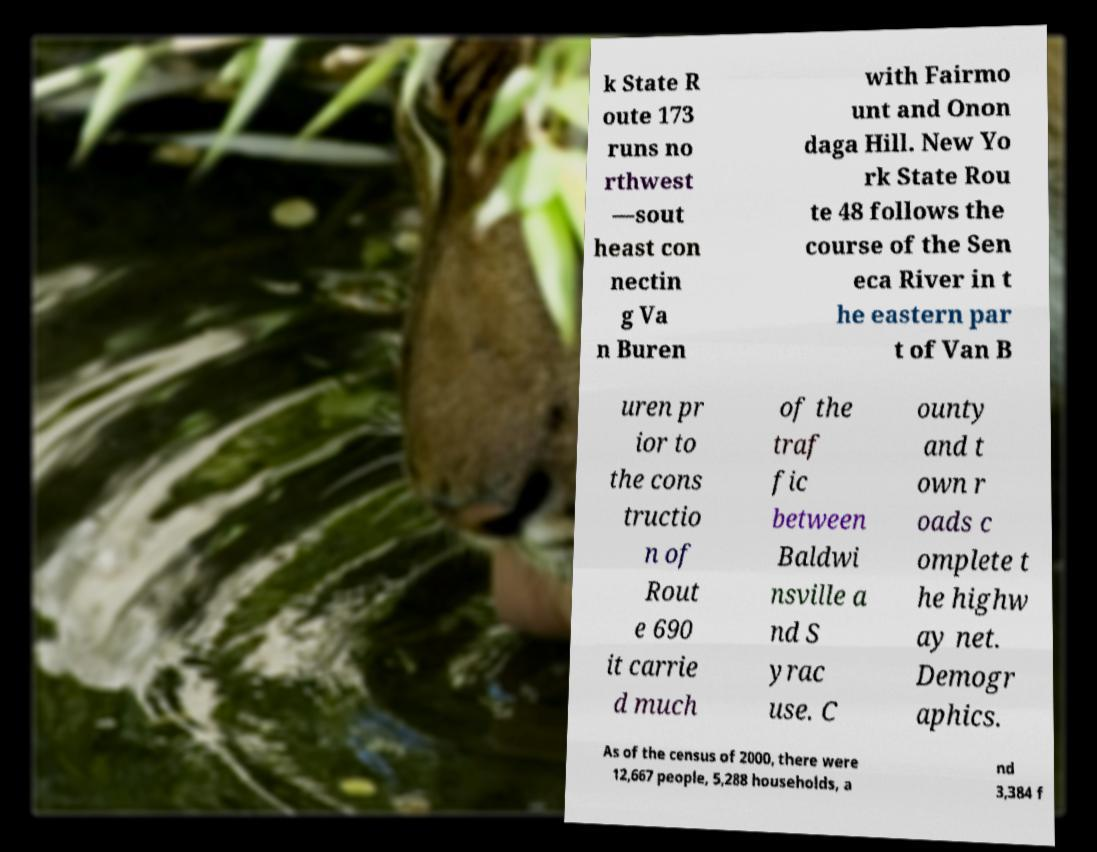Can you read and provide the text displayed in the image?This photo seems to have some interesting text. Can you extract and type it out for me? k State R oute 173 runs no rthwest —sout heast con nectin g Va n Buren with Fairmo unt and Onon daga Hill. New Yo rk State Rou te 48 follows the course of the Sen eca River in t he eastern par t of Van B uren pr ior to the cons tructio n of Rout e 690 it carrie d much of the traf fic between Baldwi nsville a nd S yrac use. C ounty and t own r oads c omplete t he highw ay net. Demogr aphics. As of the census of 2000, there were 12,667 people, 5,288 households, a nd 3,384 f 